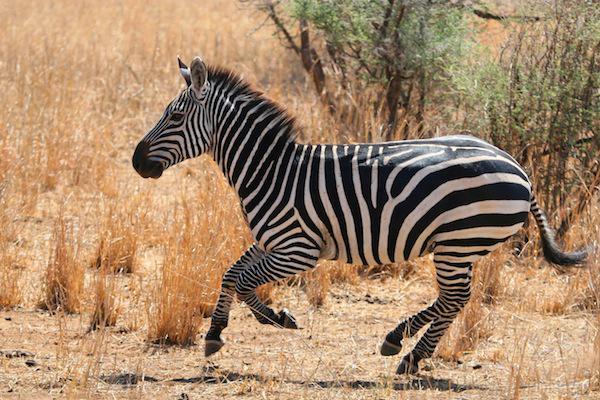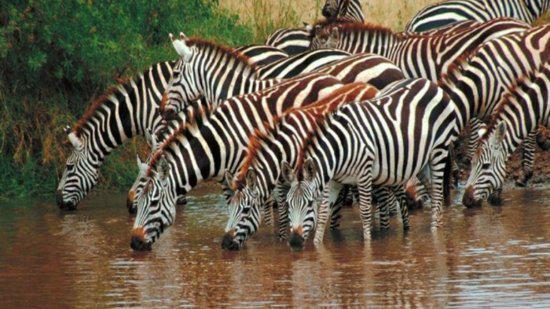The first image is the image on the left, the second image is the image on the right. Analyze the images presented: Is the assertion "The right image shows one zebra reclining on the ground with its front legs folded under its body." valid? Answer yes or no. No. The first image is the image on the left, the second image is the image on the right. Examine the images to the left and right. Is the description "The left and right image contains a total of three zebras." accurate? Answer yes or no. No. 